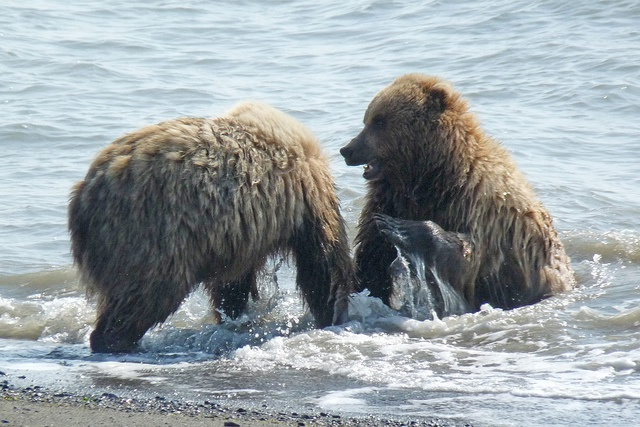Describe the objects in this image and their specific colors. I can see bear in white, black, gray, and darkgray tones and bear in white, black, gray, darkgray, and tan tones in this image. 